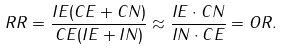Convert formula to latex. <formula><loc_0><loc_0><loc_500><loc_500>R R = { \frac { I E ( C E + C N ) } { C E ( I E + I N ) } } \approx { \frac { I E \cdot C N } { I N \cdot C E } } = O R .</formula> 